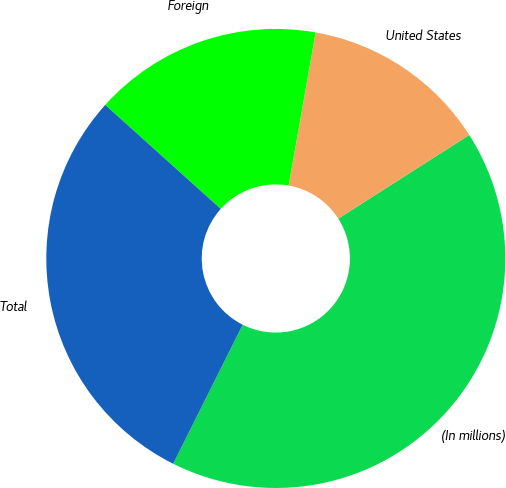<chart> <loc_0><loc_0><loc_500><loc_500><pie_chart><fcel>(In millions)<fcel>United States<fcel>Foreign<fcel>Total<nl><fcel>41.42%<fcel>13.18%<fcel>16.11%<fcel>29.29%<nl></chart> 